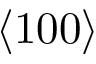<formula> <loc_0><loc_0><loc_500><loc_500>\langle 1 0 0 \rangle</formula> 